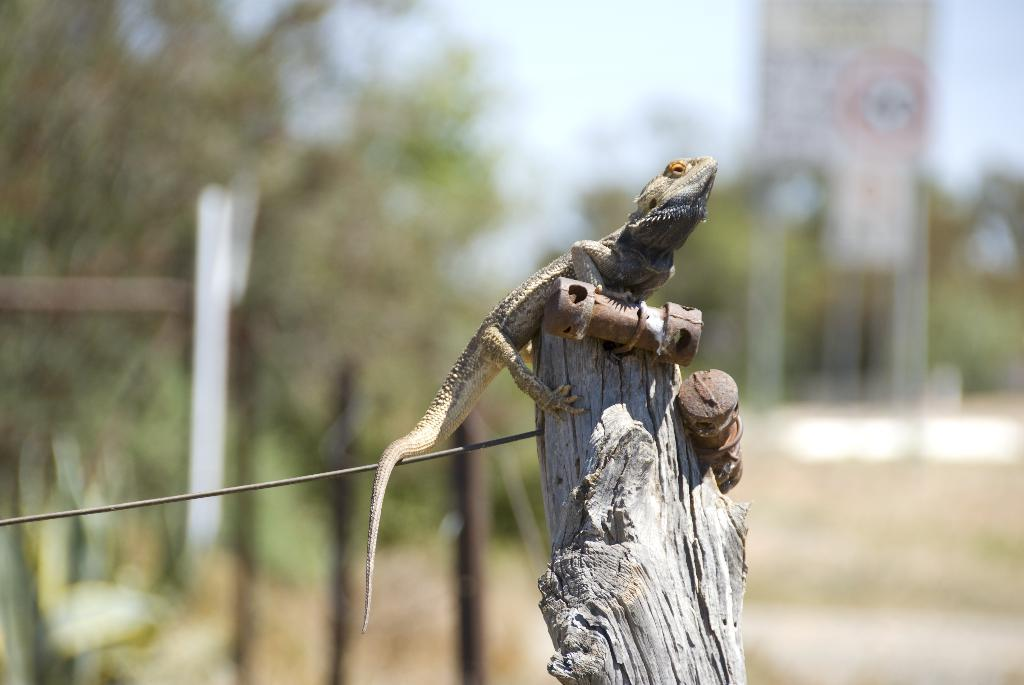What type of animal is in the image? There is a lizard in the image. What is the lizard sitting on? The lizard is on a wooden branch. What other object can be seen in the image? There is a wire in the image. How would you describe the background of the image? The background of the image appears blurred. What type of ornament is hanging from the lizard's tail in the image? There is no ornament hanging from the lizard's tail in the image; the lizard is simply sitting on a wooden branch. 